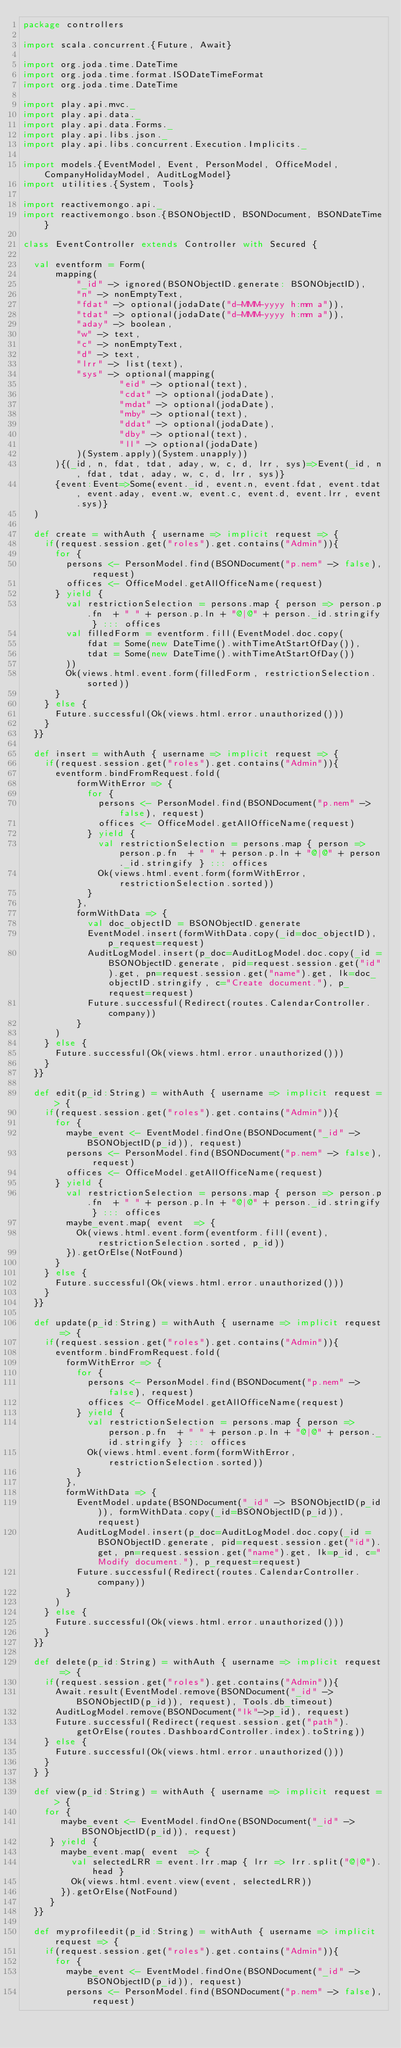Convert code to text. <code><loc_0><loc_0><loc_500><loc_500><_Scala_>package controllers

import scala.concurrent.{Future, Await}

import org.joda.time.DateTime
import org.joda.time.format.ISODateTimeFormat
import org.joda.time.DateTime

import play.api.mvc._
import play.api.data._
import play.api.data.Forms._
import play.api.libs.json._
import play.api.libs.concurrent.Execution.Implicits._

import models.{EventModel, Event, PersonModel, OfficeModel, CompanyHolidayModel, AuditLogModel}
import utilities.{System, Tools}

import reactivemongo.api._
import reactivemongo.bson.{BSONObjectID, BSONDocument, BSONDateTime}

class EventController extends Controller with Secured {
  
  val eventform = Form(
      mapping(
          "_id" -> ignored(BSONObjectID.generate: BSONObjectID),
          "n" -> nonEmptyText,
          "fdat" -> optional(jodaDate("d-MMM-yyyy h:mm a")),
          "tdat" -> optional(jodaDate("d-MMM-yyyy h:mm a")),
          "aday" -> boolean,
          "w" -> text,
          "c" -> nonEmptyText,
          "d" -> text,
          "lrr" -> list(text),
          "sys" -> optional(mapping(
                  "eid" -> optional(text),
                  "cdat" -> optional(jodaDate),
                  "mdat" -> optional(jodaDate),
                  "mby" -> optional(text),
                  "ddat" -> optional(jodaDate),
                  "dby" -> optional(text),
                  "ll" -> optional(jodaDate)
          )(System.apply)(System.unapply))  
      ){(_id, n, fdat, tdat, aday, w, c, d, lrr, sys)=>Event(_id, n, fdat, tdat, aday, w, c, d, lrr, sys)}
      {event:Event=>Some(event._id, event.n, event.fdat, event.tdat, event.aday, event.w, event.c, event.d, event.lrr, event.sys)}
  ) 
  
  def create = withAuth { username => implicit request => {
    if(request.session.get("roles").get.contains("Admin")){
      for {
        persons <- PersonModel.find(BSONDocument("p.nem" -> false), request)
        offices <- OfficeModel.getAllOfficeName(request)
      } yield {
        val restrictionSelection = persons.map { person => person.p.fn  + " " + person.p.ln + "@|@" + person._id.stringify } ::: offices
        val filledForm = eventform.fill(EventModel.doc.copy(
            fdat = Some(new DateTime().withTimeAtStartOfDay()),
            tdat = Some(new DateTime().withTimeAtStartOfDay())
        ))
        Ok(views.html.event.form(filledForm, restrictionSelection.sorted))
      }
    } else {
      Future.successful(Ok(views.html.error.unauthorized()))
    }
  }}
  
  def insert = withAuth { username => implicit request => {
    if(request.session.get("roles").get.contains("Admin")){
      eventform.bindFromRequest.fold(
          formWithError => {
            for {
              persons <- PersonModel.find(BSONDocument("p.nem" -> false), request)
              offices <- OfficeModel.getAllOfficeName(request)
            } yield {
              val restrictionSelection = persons.map { person => person.p.fn  + " " + person.p.ln + "@|@" + person._id.stringify } ::: offices
              Ok(views.html.event.form(formWithError, restrictionSelection.sorted))
            }
          },
          formWithData => {
            val doc_objectID = BSONObjectID.generate
            EventModel.insert(formWithData.copy(_id=doc_objectID), p_request=request)
            AuditLogModel.insert(p_doc=AuditLogModel.doc.copy(_id =BSONObjectID.generate, pid=request.session.get("id").get, pn=request.session.get("name").get, lk=doc_objectID.stringify, c="Create document."), p_request=request)
            Future.successful(Redirect(routes.CalendarController.company))
          }
      )
    } else {
      Future.successful(Ok(views.html.error.unauthorized()))
    }
  }}
  
  def edit(p_id:String) = withAuth { username => implicit request => {
    if(request.session.get("roles").get.contains("Admin")){
      for { 
        maybe_event <- EventModel.findOne(BSONDocument("_id" -> BSONObjectID(p_id)), request)
        persons <- PersonModel.find(BSONDocument("p.nem" -> false), request)
        offices <- OfficeModel.getAllOfficeName(request)
      } yield {
        val restrictionSelection = persons.map { person => person.p.fn  + " " + person.p.ln + "@|@" + person._id.stringify } ::: offices
        maybe_event.map( event  => {
          Ok(views.html.event.form(eventform.fill(event), restrictionSelection.sorted, p_id))
        }).getOrElse(NotFound)
      }
    } else {
      Future.successful(Ok(views.html.error.unauthorized()))
    }
  }}
    
  def update(p_id:String) = withAuth { username => implicit request => {
    if(request.session.get("roles").get.contains("Admin")){
      eventform.bindFromRequest.fold(
        formWithError => {
          for {
            persons <- PersonModel.find(BSONDocument("p.nem" -> false), request)
            offices <- OfficeModel.getAllOfficeName(request)
          } yield {
            val restrictionSelection = persons.map { person => person.p.fn  + " " + person.p.ln + "@|@" + person._id.stringify } ::: offices
            Ok(views.html.event.form(formWithError, restrictionSelection.sorted))
          } 
        },
        formWithData => {
          EventModel.update(BSONDocument("_id" -> BSONObjectID(p_id)), formWithData.copy(_id=BSONObjectID(p_id)), request)
          AuditLogModel.insert(p_doc=AuditLogModel.doc.copy(_id =BSONObjectID.generate, pid=request.session.get("id").get, pn=request.session.get("name").get, lk=p_id, c="Modify document."), p_request=request)  
          Future.successful(Redirect(routes.CalendarController.company))
        }
      )
    } else {
      Future.successful(Ok(views.html.error.unauthorized()))
    }
  }}
  
  def delete(p_id:String) = withAuth { username => implicit request => {
    if(request.session.get("roles").get.contains("Admin")){
      Await.result(EventModel.remove(BSONDocument("_id" -> BSONObjectID(p_id)), request), Tools.db_timeout)
      AuditLogModel.remove(BSONDocument("lk"->p_id), request)
      Future.successful(Redirect(request.session.get("path").getOrElse(routes.DashboardController.index).toString))
    } else {
      Future.successful(Ok(views.html.error.unauthorized()))
    }
  } }
  
  def view(p_id:String) = withAuth { username => implicit request => {
    for { 
       maybe_event <- EventModel.findOne(BSONDocument("_id" -> BSONObjectID(p_id)), request)
     } yield {
       maybe_event.map( event  => {
         val selectedLRR = event.lrr.map { lrr => lrr.split("@|@").head }
         Ok(views.html.event.view(event, selectedLRR))
       }).getOrElse(NotFound)
     }
  }}
  
  def myprofileedit(p_id:String) = withAuth { username => implicit request => {
    if(request.session.get("roles").get.contains("Admin")){
      for { 
        maybe_event <- EventModel.findOne(BSONDocument("_id" -> BSONObjectID(p_id)), request)
        persons <- PersonModel.find(BSONDocument("p.nem" -> false), request)</code> 